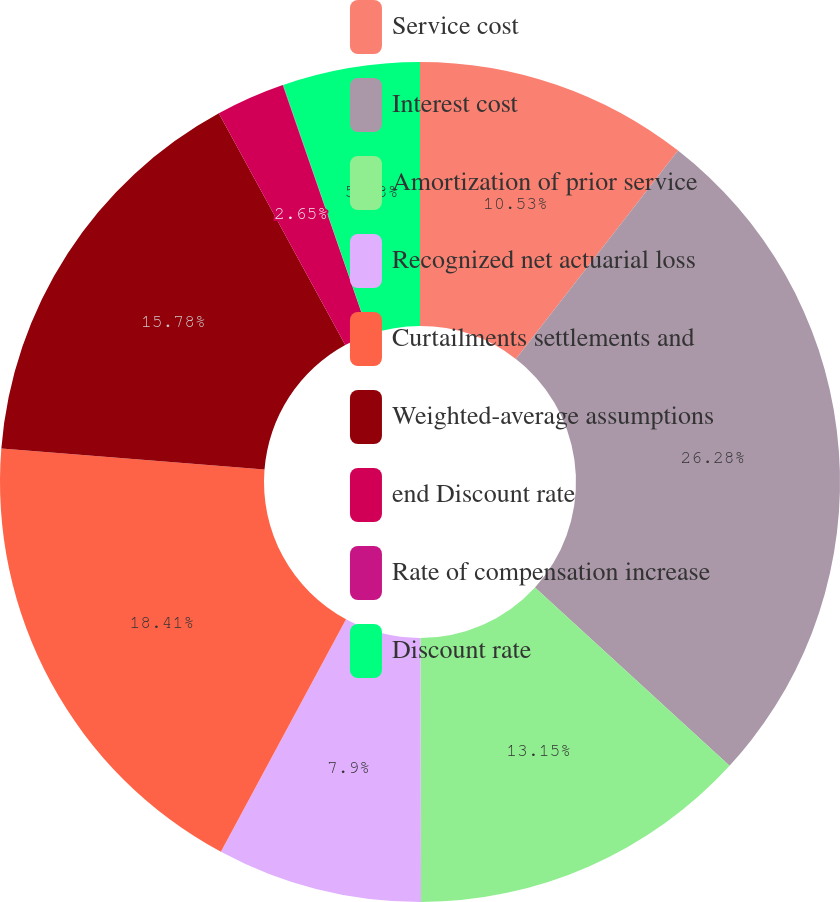Convert chart. <chart><loc_0><loc_0><loc_500><loc_500><pie_chart><fcel>Service cost<fcel>Interest cost<fcel>Amortization of prior service<fcel>Recognized net actuarial loss<fcel>Curtailments settlements and<fcel>Weighted-average assumptions<fcel>end Discount rate<fcel>Rate of compensation increase<fcel>Discount rate<nl><fcel>10.53%<fcel>26.28%<fcel>13.15%<fcel>7.9%<fcel>18.41%<fcel>15.78%<fcel>2.65%<fcel>0.02%<fcel>5.28%<nl></chart> 